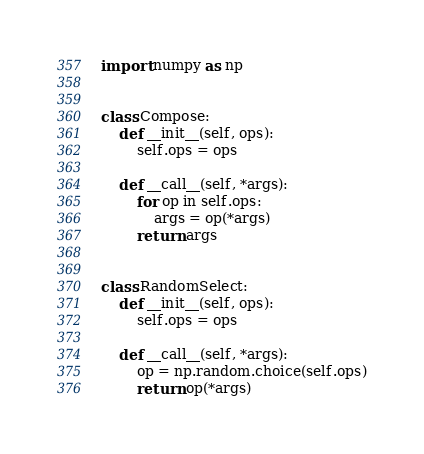Convert code to text. <code><loc_0><loc_0><loc_500><loc_500><_Python_>import numpy as np


class Compose:
    def __init__(self, ops):
        self.ops = ops

    def __call__(self, *args):
        for op in self.ops:
            args = op(*args)
        return args


class RandomSelect:
    def __init__(self, ops):
        self.ops = ops

    def __call__(self, *args):
        op = np.random.choice(self.ops)
        return op(*args)
</code> 